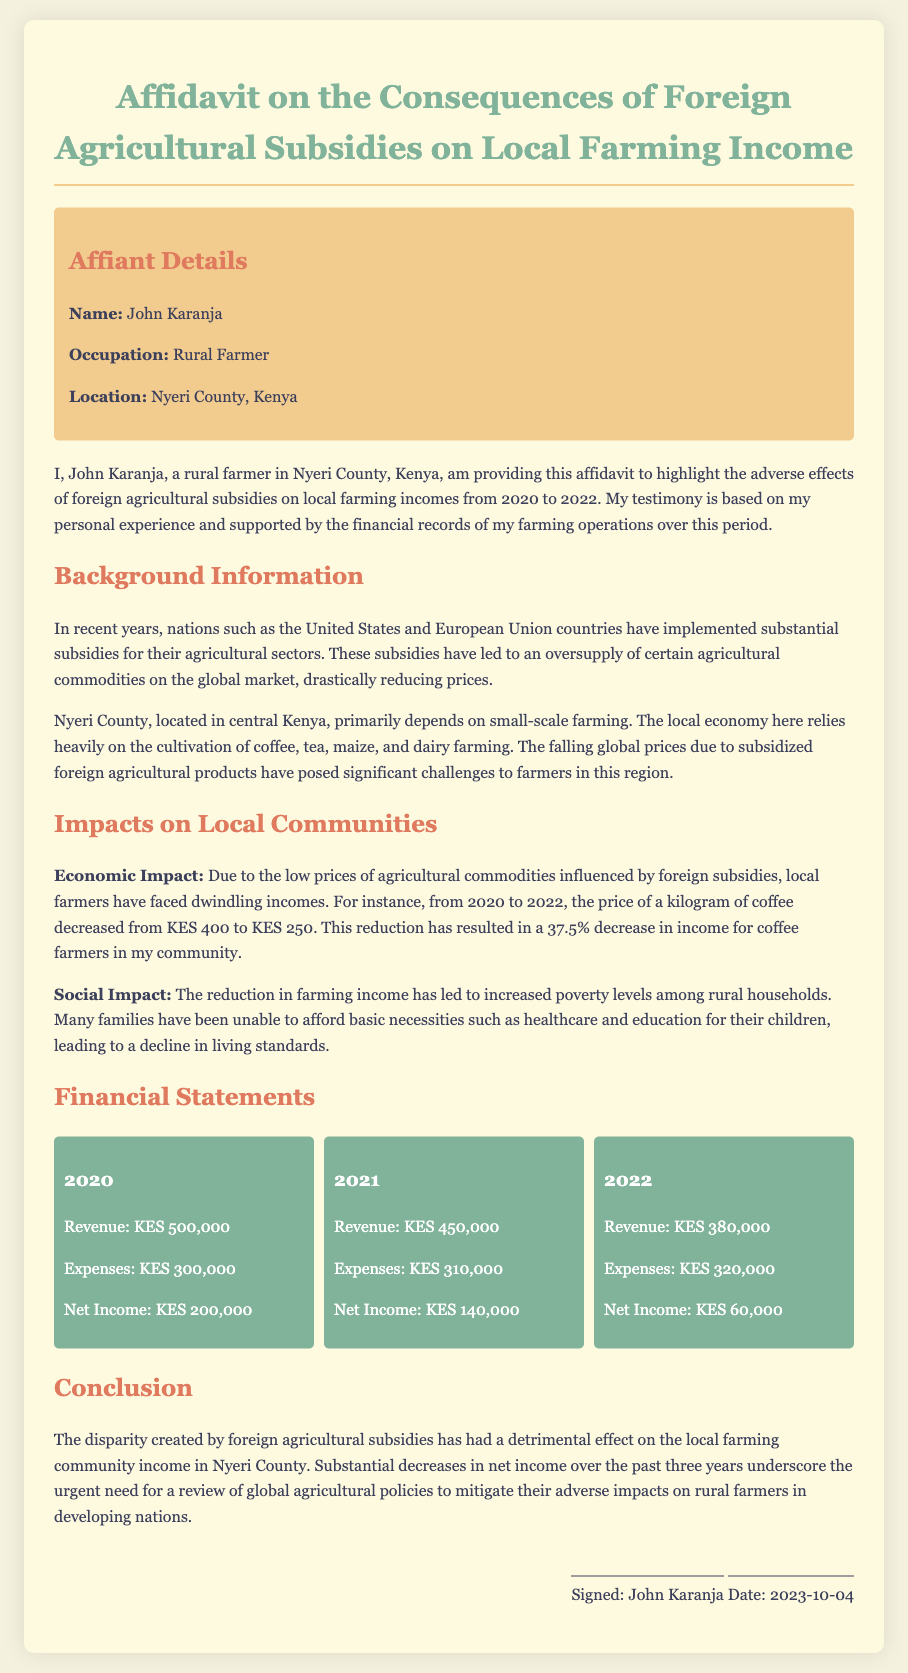What is the name of the affiant? The name of the affiant mentioned in the document is at the beginning under "Affiant Details."
Answer: John Karanja What is the location of the affiant? The location of the affiant is specified in the "Affiant Details" section.
Answer: Nyeri County, Kenya What was the net income in 2020? The net income for 2020 is outlined in the "Financial Statements" section.
Answer: KES 200,000 How much did the price of a kilogram of coffee decrease? The document states that the price of coffee decreased from KES 400 to KES 250, providing specific amounts to calculate the decrease.
Answer: 37.5% What is the total revenue across all three years? The total revenue is the sum of the revenue figures provided for each year (2020, 2021, 2022).
Answer: KES 1,330,000 What were the expenses in 2021? The expenses for the year 2021 are specifically stated in the "Financial Statements" section.
Answer: KES 310,000 Which year showed the lowest net income? The document provides the net income for each year, allowing comparison to identify the lowest.
Answer: 2022 What are the main agricultural products mentioned in the affidavit? The affidavit lists the primary agricultural products in the background section.
Answer: Coffee, tea, maize, and dairy What date was the affidavit signed? The signing date of the affidavit is mentioned at the end of the document.
Answer: 2023-10-04 